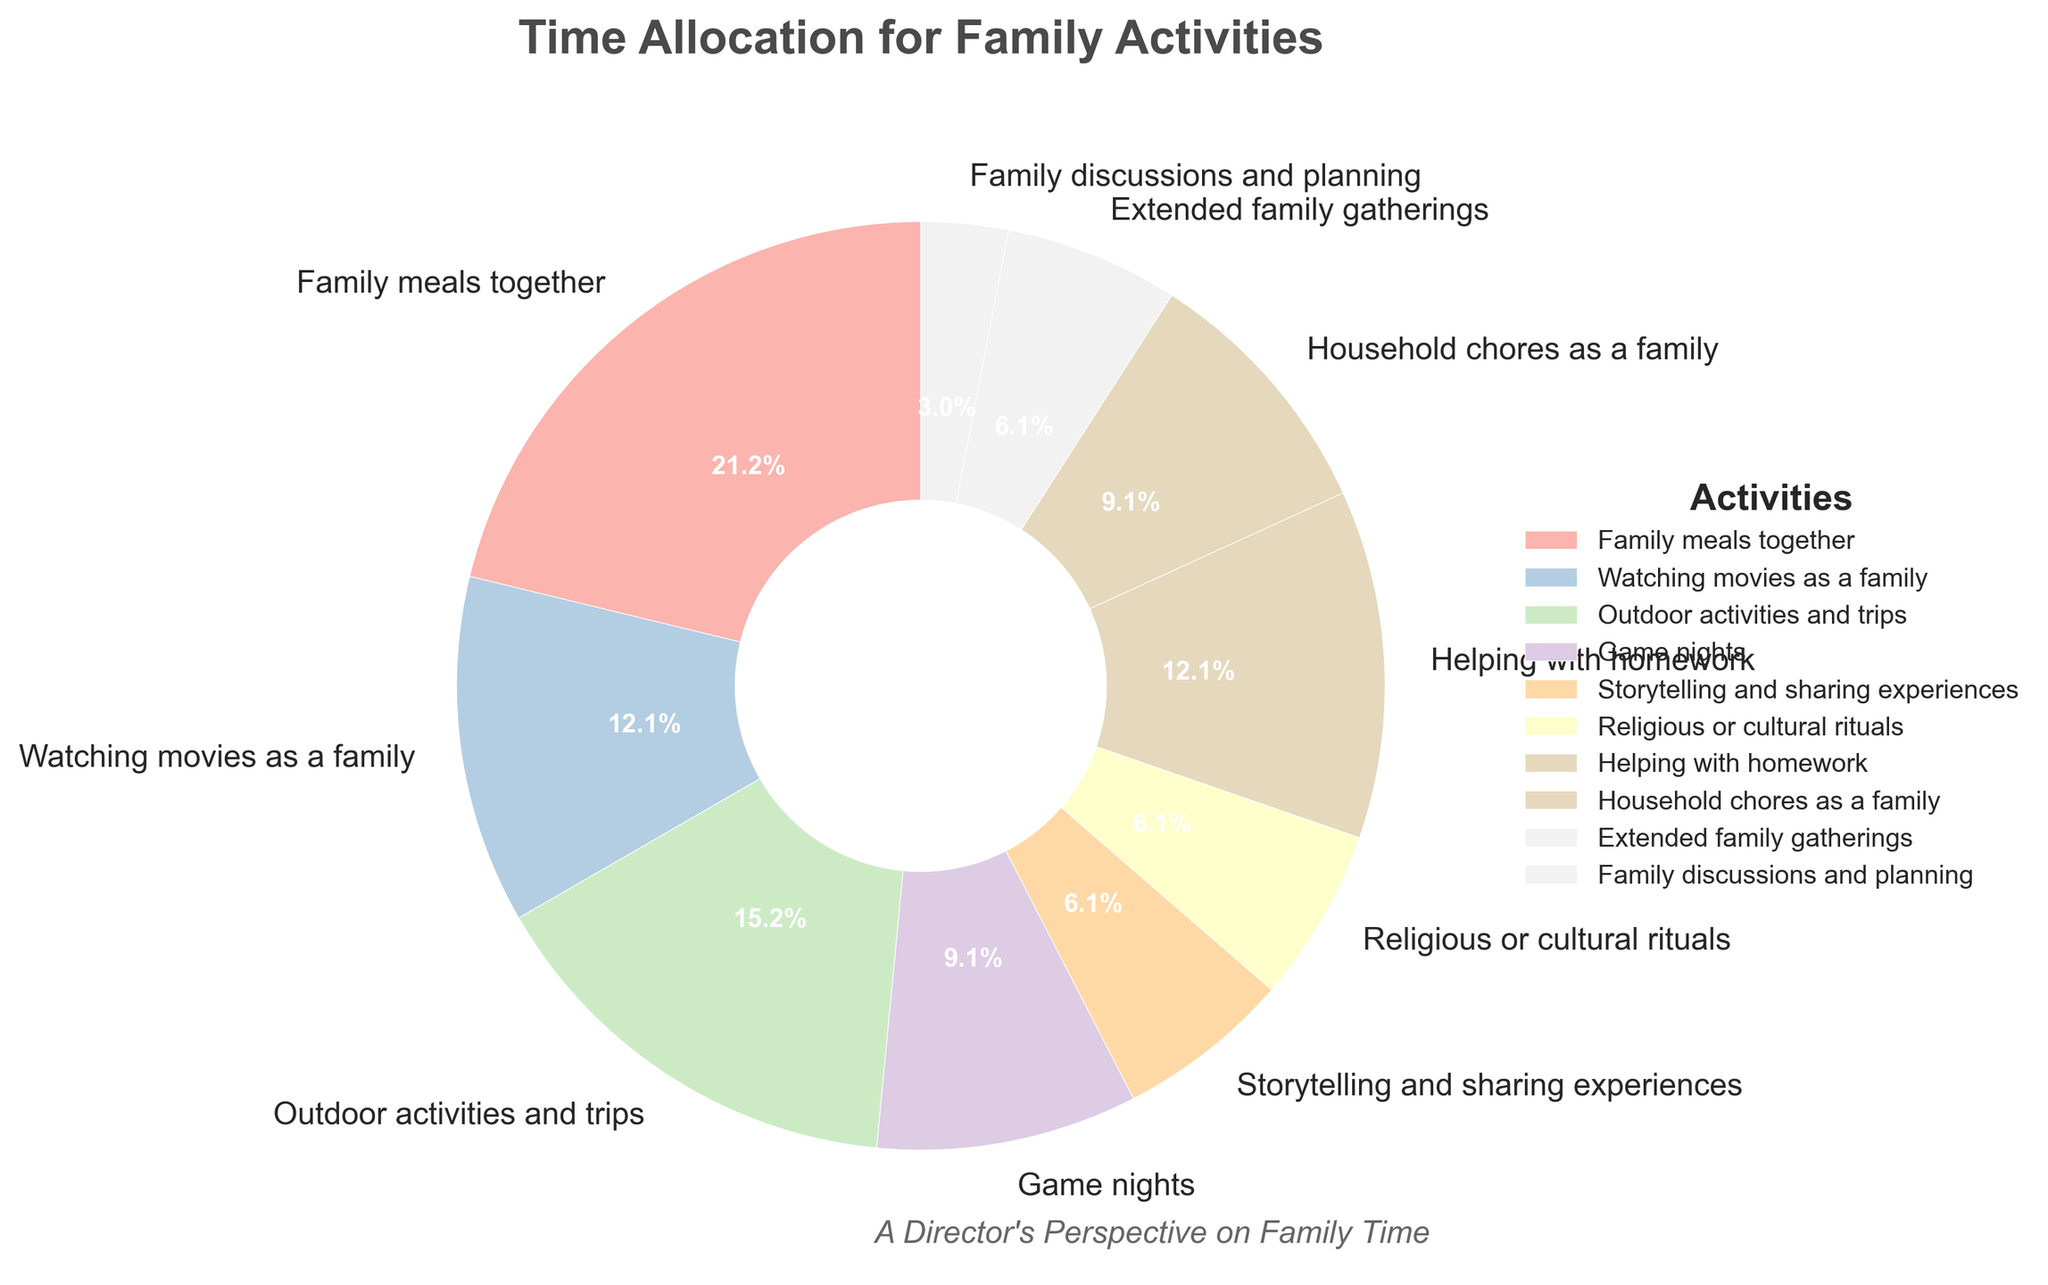How many hours per week are spent on activities involving outdoor and group family activities combined? To find the total number of hours spent on outdoor activities and group family activities, we sum the hours for "Outdoor activities and trips" (5 hours), "Extended family gatherings" (2 hours), and "Household chores as a family" (3 hours). So, 5 + 2 + 3 = 10 hours per week.
Answer: 10 Which activity has the highest time allocation, and how many more hours are spent on this activity compared to "Watching movies as a family"? "Family meals together" has the highest time allocation with 7 hours per week. "Watching movies as a family" is allocated 4 hours per week. The difference is 7 - 4 = 3 hours.
Answer: Family meals together, 3 hours more What percentage of time is spent on storytelling and sharing experiences? From the pie chart, "Storytelling and sharing experiences" occupies 2 hours per week out of a total of 33 hours (sum of all hours). The percentage can be calculated as (2 / 33) * 100 ≈ 6.1%.
Answer: 6.1% Compare the hours spent on helping with homework and household chores as a family. Which is greater, and by how much? "Helping with homework" has 4 hours per week, and "Household chores as a family" has 3 hours per week. The difference is 4 - 3 = 1 hour. Thus, more time is spent helping with homework by 1 hour.
Answer: Helping with homework, 1 hour more What is the total time spent on activities that involve more than 3 hours per week each? Activities with more than 3 hours per week are "Family meals together" (7 hours), "Watching movies as a family" (4 hours), "Outdoor activities and trips" (5 hours), and "Helping with homework" (4 hours). Summing these, 7 + 4 + 5 + 4 = 20 hours per week.
Answer: 20 Identify the activity with the least time allocation in the pie chart. The activity labeled "Family discussions and planning" has the least time allocation with 1 hour per week.
Answer: Family discussions and planning Which activities occupy the same percentage of time? Both "Storytelling and sharing experiences" and "Religious or cultural rituals" each have an allocation of 2 hours per week, which is the same percentage when compared to the total hours.
Answer: Storytelling and sharing experiences, Religious or cultural rituals Rank the top three activities by the number of hours per week. The top three activities by hours per week are: 1) Family meals together (7 hours), 2) Outdoor activities and trips (5 hours), 3) Watching movies as a family and Helping with homework (tied at 4 hours each).
Answer: Family meals together, Outdoor activities and trips, Watching movies as a family and Helping with homework What is the difference in time spent on game nights versus extended family gatherings? Game nights are allocated 3 hours per week, while extended family gatherings are 2 hours per week. The difference is 3 - 2 = 1 hour.
Answer: 1 hour 